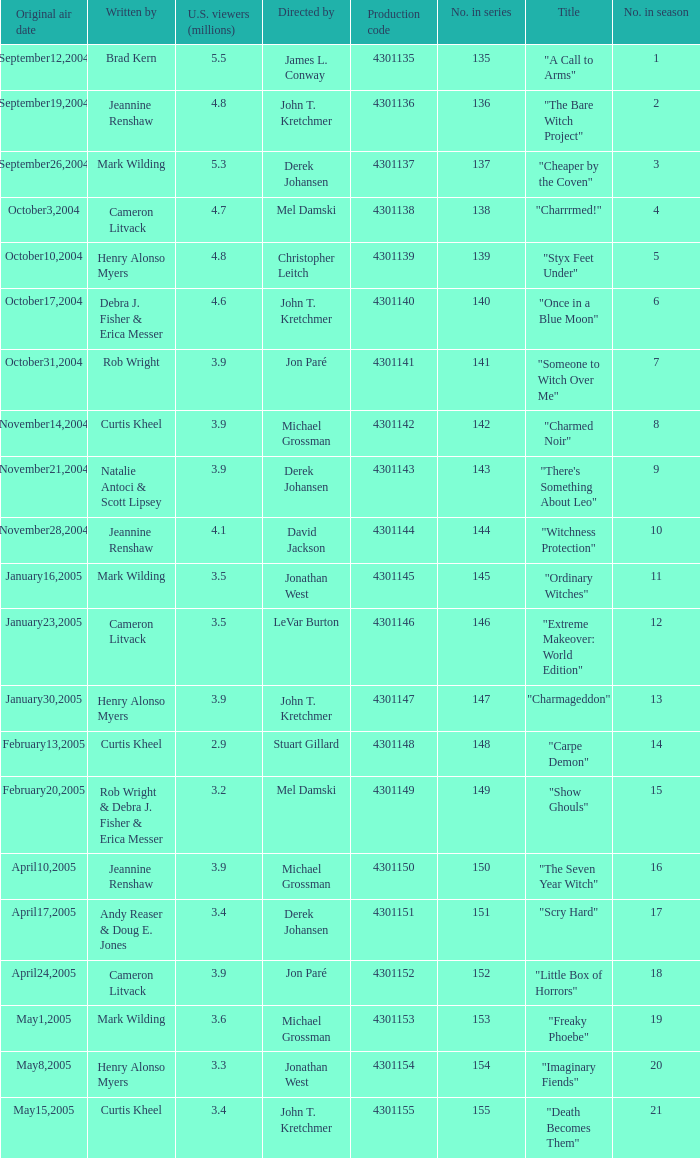Who were the directors of the episode called "someone to witch over me"? Jon Paré. 